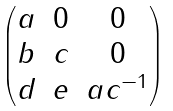<formula> <loc_0><loc_0><loc_500><loc_500>\begin{pmatrix} a & 0 & 0 \\ b & c & 0 \\ d & e & a c ^ { - 1 } \end{pmatrix}</formula> 